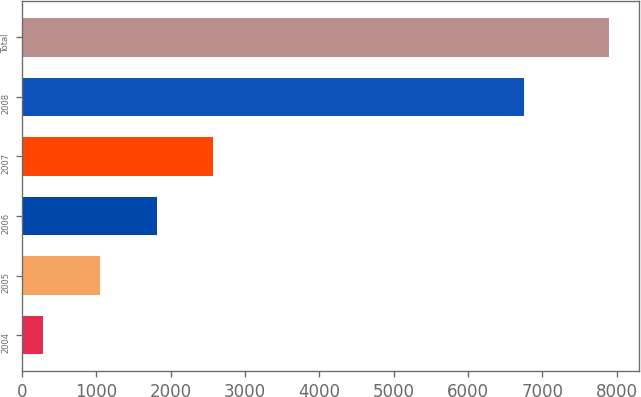<chart> <loc_0><loc_0><loc_500><loc_500><bar_chart><fcel>2004<fcel>2005<fcel>2006<fcel>2007<fcel>2008<fcel>Total<nl><fcel>288<fcel>1049.6<fcel>1811.2<fcel>2572.8<fcel>6752<fcel>7904<nl></chart> 